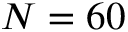Convert formula to latex. <formula><loc_0><loc_0><loc_500><loc_500>N = 6 0</formula> 